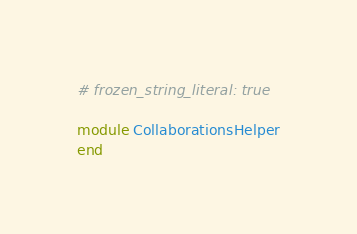Convert code to text. <code><loc_0><loc_0><loc_500><loc_500><_Ruby_># frozen_string_literal: true

module CollaborationsHelper
end
</code> 